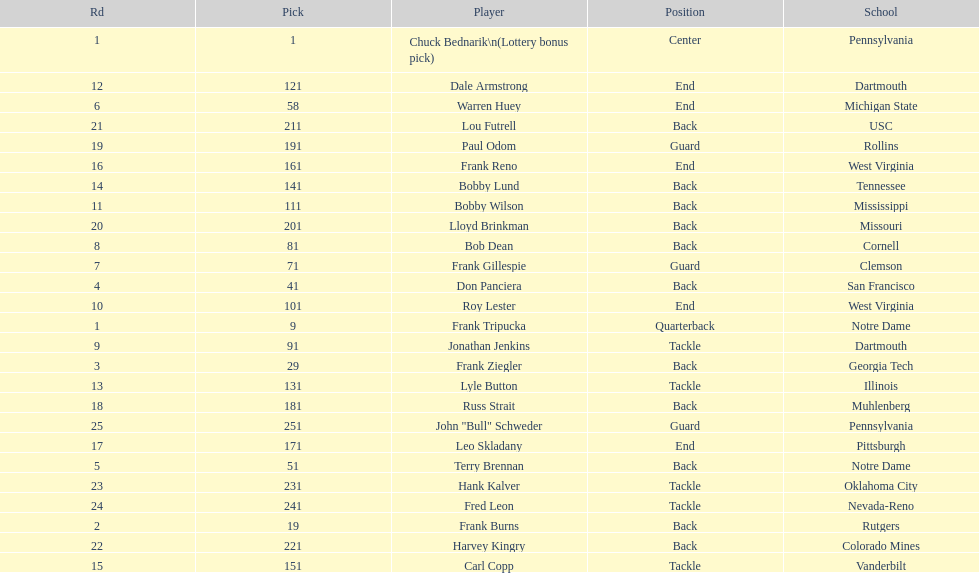How many players were from notre dame? 2. 